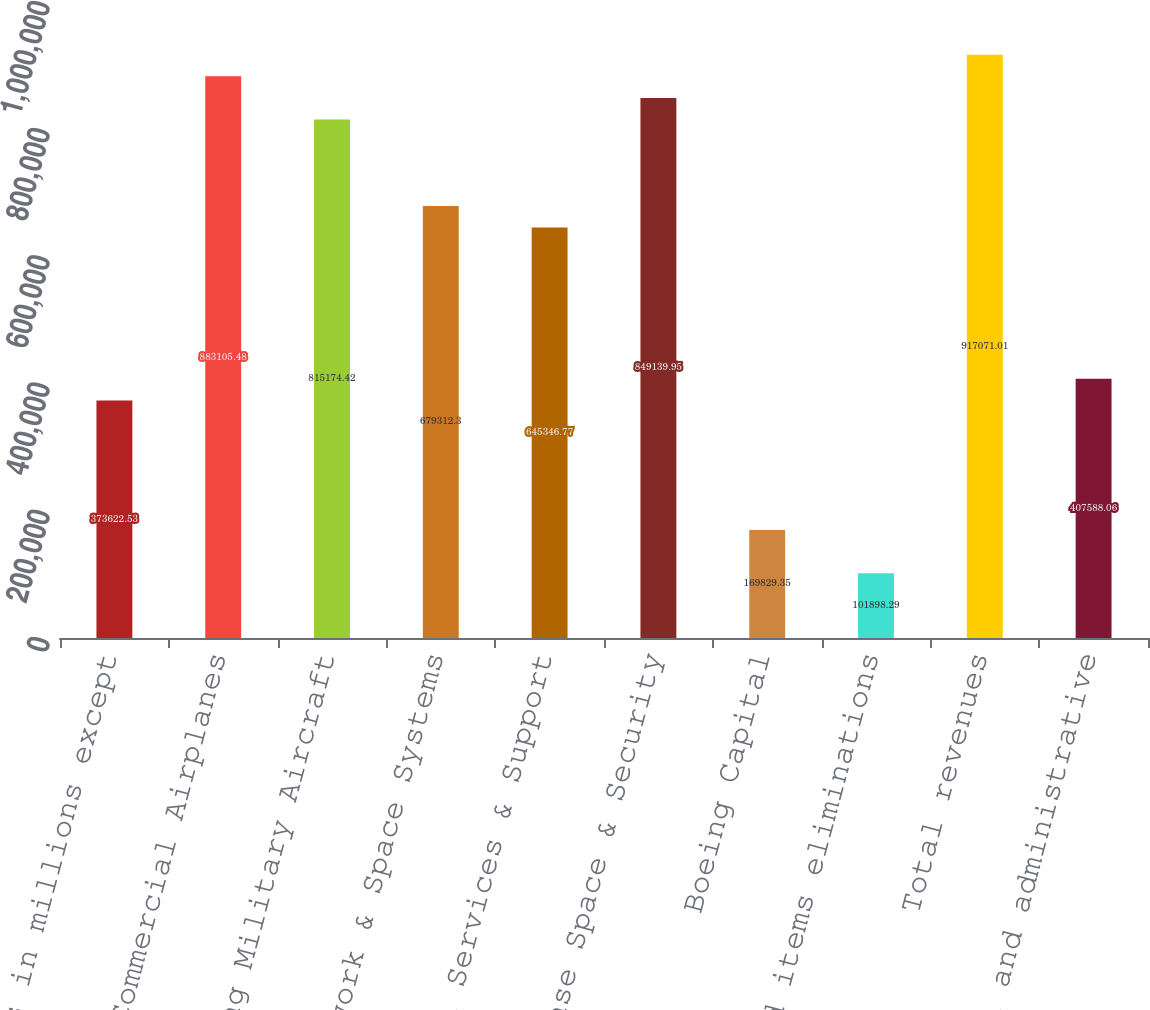Convert chart to OTSL. <chart><loc_0><loc_0><loc_500><loc_500><bar_chart><fcel>(Dollars in millions except<fcel>Commercial Airplanes<fcel>Boeing Military Aircraft<fcel>Network & Space Systems<fcel>Global Services & Support<fcel>Total Defense Space & Security<fcel>Boeing Capital<fcel>Unallocated items eliminations<fcel>Total revenues<fcel>General and administrative<nl><fcel>373623<fcel>883105<fcel>815174<fcel>679312<fcel>645347<fcel>849140<fcel>169829<fcel>101898<fcel>917071<fcel>407588<nl></chart> 